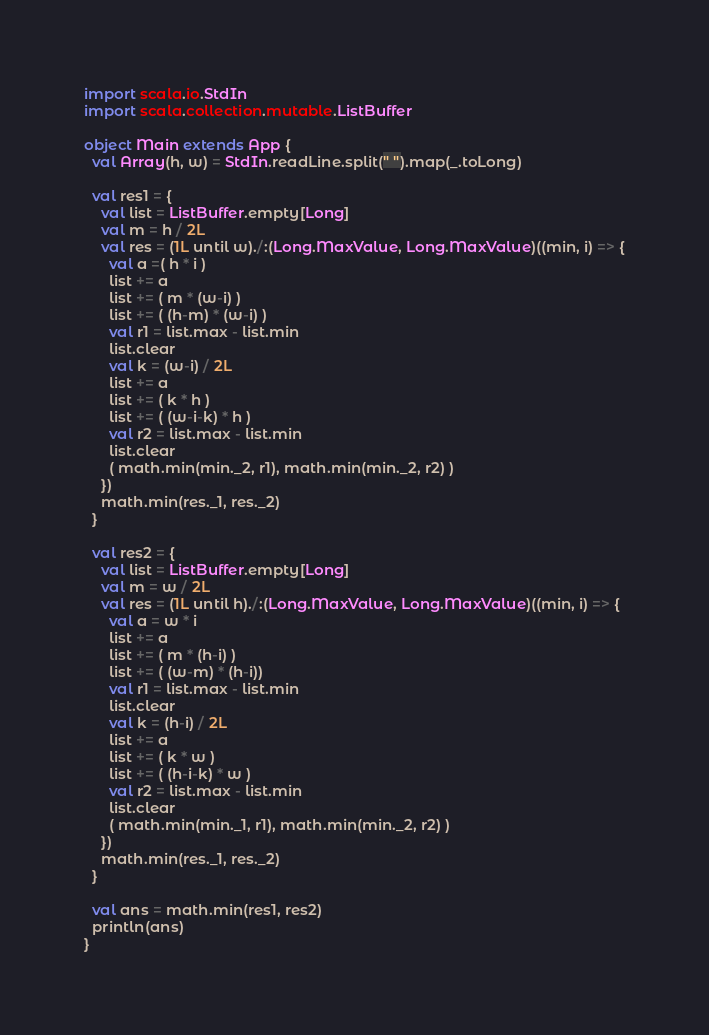<code> <loc_0><loc_0><loc_500><loc_500><_Scala_>import scala.io.StdIn
import scala.collection.mutable.ListBuffer

object Main extends App {
  val Array(h, w) = StdIn.readLine.split(" ").map(_.toLong)

  val res1 = {
    val list = ListBuffer.empty[Long]
    val m = h / 2L
    val res = (1L until w)./:(Long.MaxValue, Long.MaxValue)((min, i) => {
      val a =( h * i ) 
      list += a
      list += ( m * (w-i) )
      list += ( (h-m) * (w-i) )
      val r1 = list.max - list.min
      list.clear
      val k = (w-i) / 2L
      list += a
      list += ( k * h )
      list += ( (w-i-k) * h )
      val r2 = list.max - list.min
      list.clear
      ( math.min(min._2, r1), math.min(min._2, r2) )
    })
    math.min(res._1, res._2)
  }

  val res2 = {
    val list = ListBuffer.empty[Long]
    val m = w / 2L
    val res = (1L until h)./:(Long.MaxValue, Long.MaxValue)((min, i) => {
      val a = w * i
      list += a
      list += ( m * (h-i) )
      list += ( (w-m) * (h-i))
      val r1 = list.max - list.min
      list.clear
      val k = (h-i) / 2L
      list += a
      list += ( k * w )
      list += ( (h-i-k) * w )
      val r2 = list.max - list.min
      list.clear
      ( math.min(min._1, r1), math.min(min._2, r2) )
    })
    math.min(res._1, res._2)
  }

  val ans = math.min(res1, res2)
  println(ans)
}</code> 